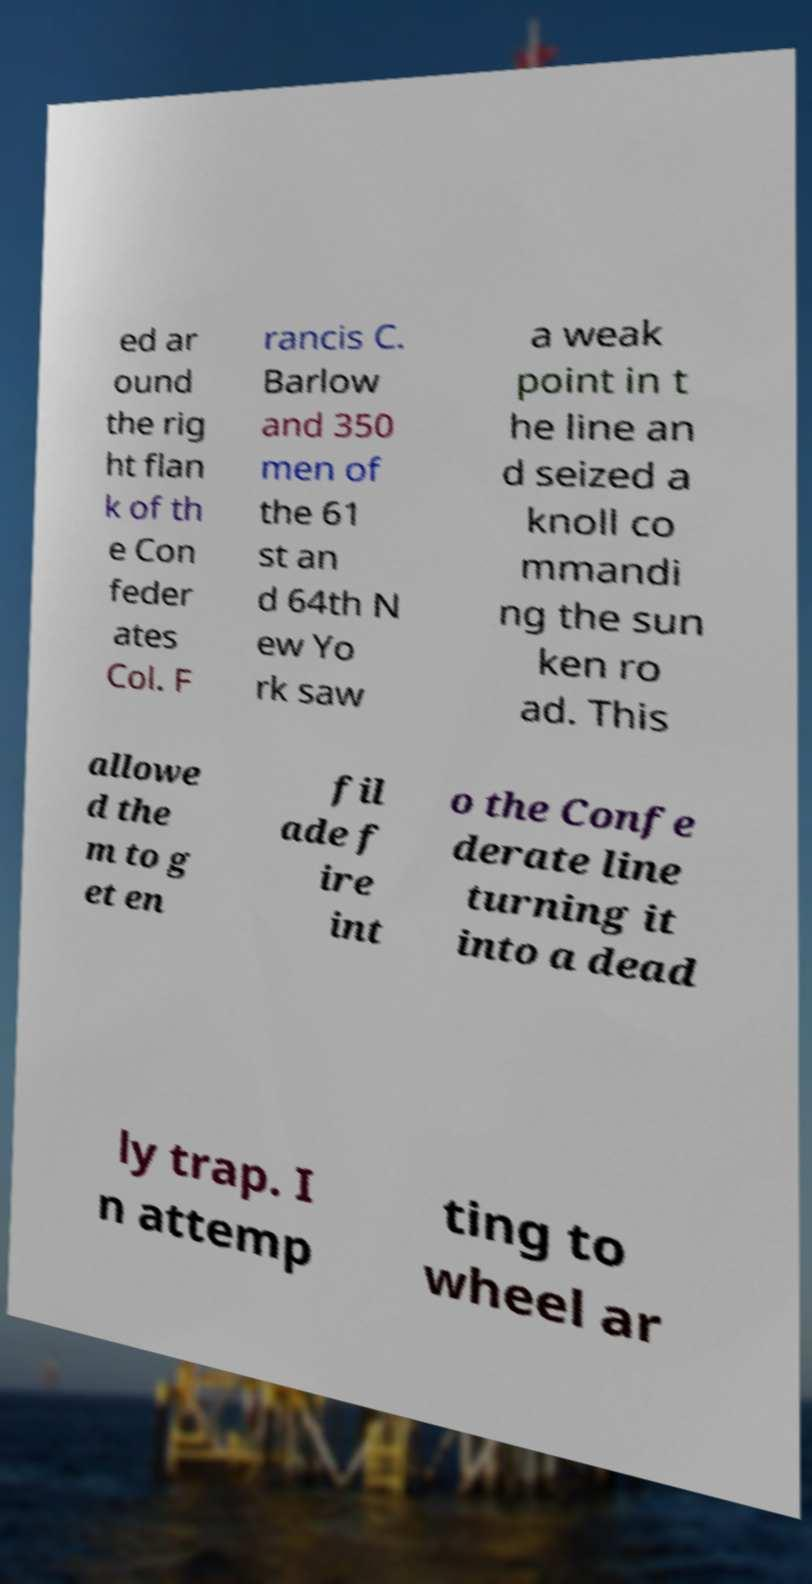I need the written content from this picture converted into text. Can you do that? ed ar ound the rig ht flan k of th e Con feder ates Col. F rancis C. Barlow and 350 men of the 61 st an d 64th N ew Yo rk saw a weak point in t he line an d seized a knoll co mmandi ng the sun ken ro ad. This allowe d the m to g et en fil ade f ire int o the Confe derate line turning it into a dead ly trap. I n attemp ting to wheel ar 